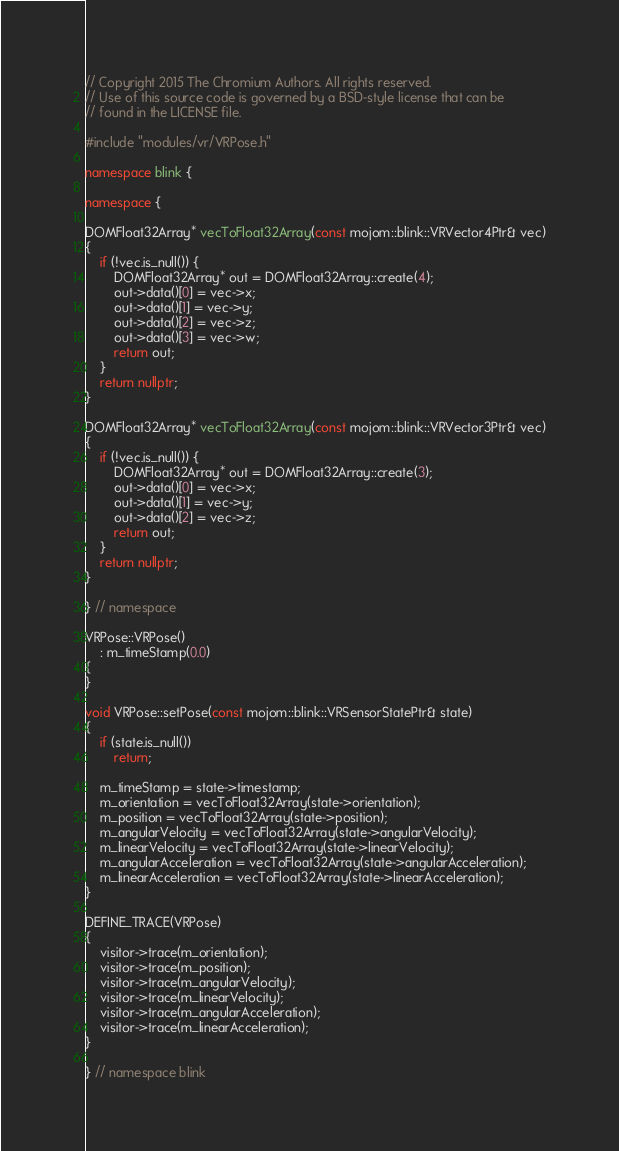Convert code to text. <code><loc_0><loc_0><loc_500><loc_500><_C++_>// Copyright 2015 The Chromium Authors. All rights reserved.
// Use of this source code is governed by a BSD-style license that can be
// found in the LICENSE file.

#include "modules/vr/VRPose.h"

namespace blink {

namespace {

DOMFloat32Array* vecToFloat32Array(const mojom::blink::VRVector4Ptr& vec)
{
    if (!vec.is_null()) {
        DOMFloat32Array* out = DOMFloat32Array::create(4);
        out->data()[0] = vec->x;
        out->data()[1] = vec->y;
        out->data()[2] = vec->z;
        out->data()[3] = vec->w;
        return out;
    }
    return nullptr;
}

DOMFloat32Array* vecToFloat32Array(const mojom::blink::VRVector3Ptr& vec)
{
    if (!vec.is_null()) {
        DOMFloat32Array* out = DOMFloat32Array::create(3);
        out->data()[0] = vec->x;
        out->data()[1] = vec->y;
        out->data()[2] = vec->z;
        return out;
    }
    return nullptr;
}

} // namespace

VRPose::VRPose()
    : m_timeStamp(0.0)
{
}

void VRPose::setPose(const mojom::blink::VRSensorStatePtr& state)
{
    if (state.is_null())
        return;

    m_timeStamp = state->timestamp;
    m_orientation = vecToFloat32Array(state->orientation);
    m_position = vecToFloat32Array(state->position);
    m_angularVelocity = vecToFloat32Array(state->angularVelocity);
    m_linearVelocity = vecToFloat32Array(state->linearVelocity);
    m_angularAcceleration = vecToFloat32Array(state->angularAcceleration);
    m_linearAcceleration = vecToFloat32Array(state->linearAcceleration);
}

DEFINE_TRACE(VRPose)
{
    visitor->trace(m_orientation);
    visitor->trace(m_position);
    visitor->trace(m_angularVelocity);
    visitor->trace(m_linearVelocity);
    visitor->trace(m_angularAcceleration);
    visitor->trace(m_linearAcceleration);
}

} // namespace blink
</code> 